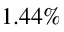Convert formula to latex. <formula><loc_0><loc_0><loc_500><loc_500>1 . 4 4 \%</formula> 